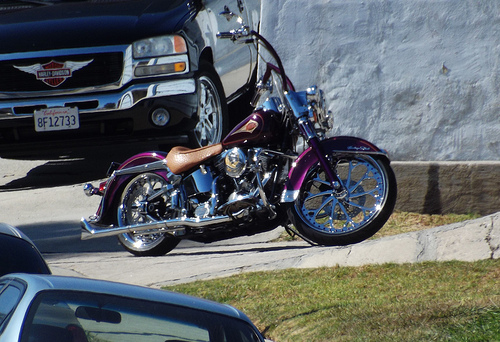<image>
Can you confirm if the bike is behind the car? No. The bike is not behind the car. From this viewpoint, the bike appears to be positioned elsewhere in the scene. 